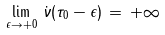Convert formula to latex. <formula><loc_0><loc_0><loc_500><loc_500>\lim _ { \epsilon \rightarrow + 0 } \, \dot { \nu } ( \tau _ { 0 } - \epsilon ) \, = \, + \infty</formula> 